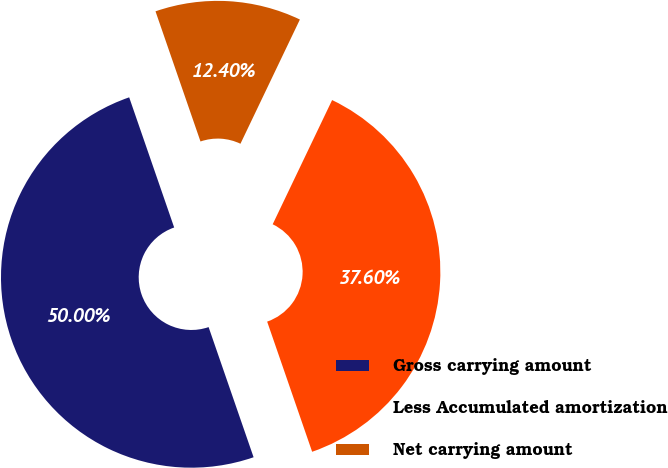<chart> <loc_0><loc_0><loc_500><loc_500><pie_chart><fcel>Gross carrying amount<fcel>Less Accumulated amortization<fcel>Net carrying amount<nl><fcel>50.0%<fcel>37.6%<fcel>12.4%<nl></chart> 